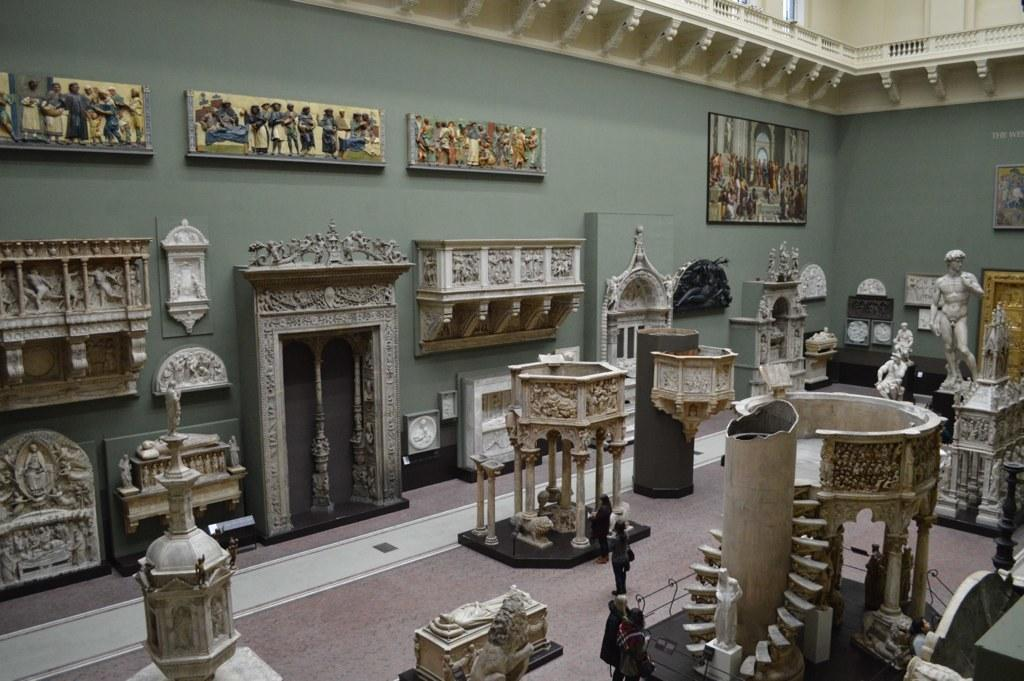What type of artworks are present in the image? There are statues and sculptures in the image. What else can be seen on the wall in the image? There are photo frames on the wall in the image. What can be inferred about the location of the image? The image appears to be an inner view of a building. What type of pain is depicted in the sculpture in the image? There is no indication of pain or any specific emotion in the sculpture in the image. 